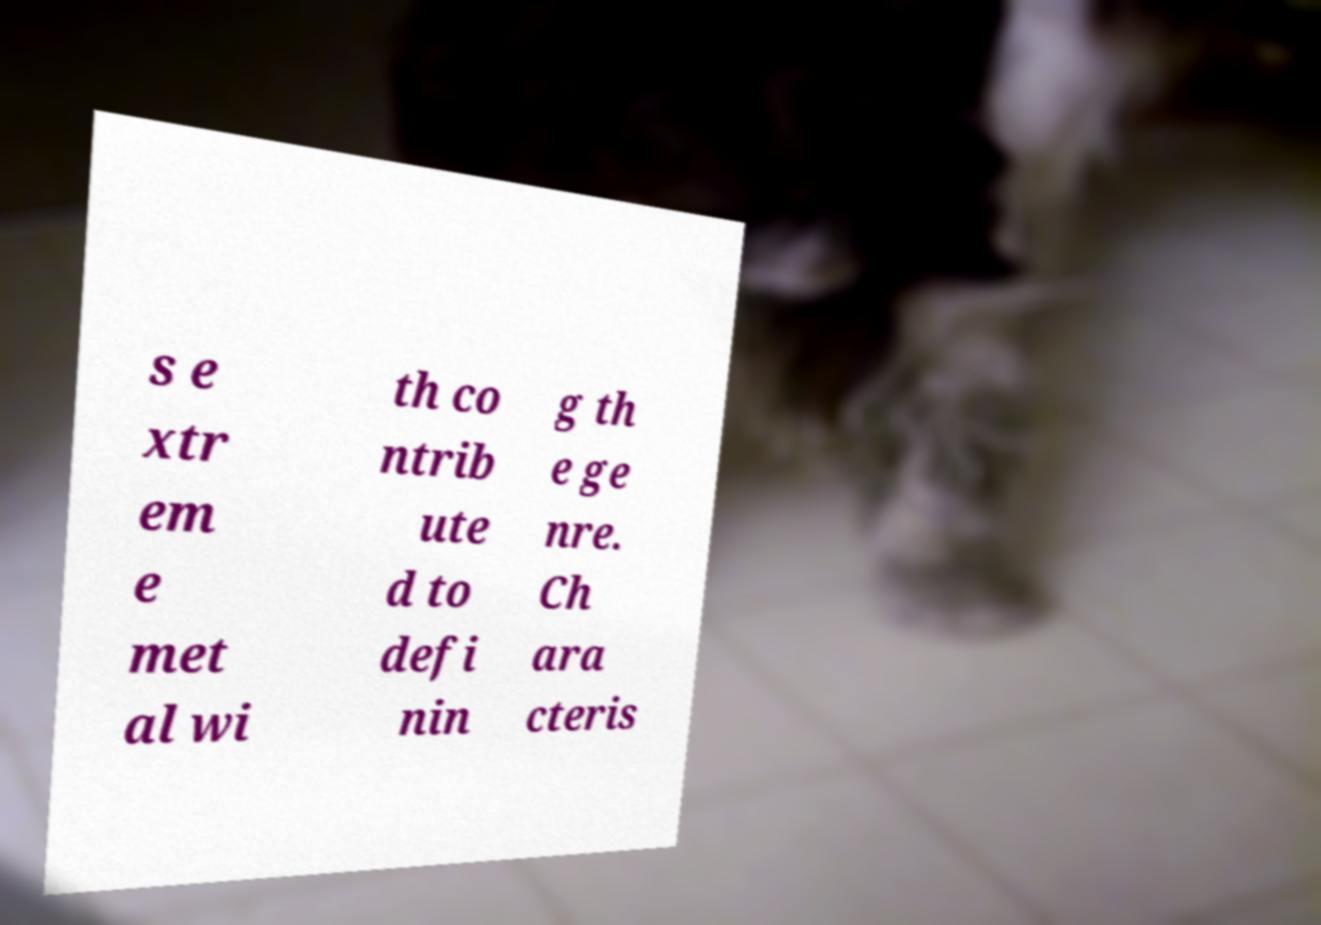I need the written content from this picture converted into text. Can you do that? s e xtr em e met al wi th co ntrib ute d to defi nin g th e ge nre. Ch ara cteris 